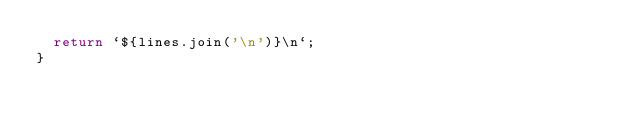Convert code to text. <code><loc_0><loc_0><loc_500><loc_500><_TypeScript_>  return `${lines.join('\n')}\n`;
}
</code> 